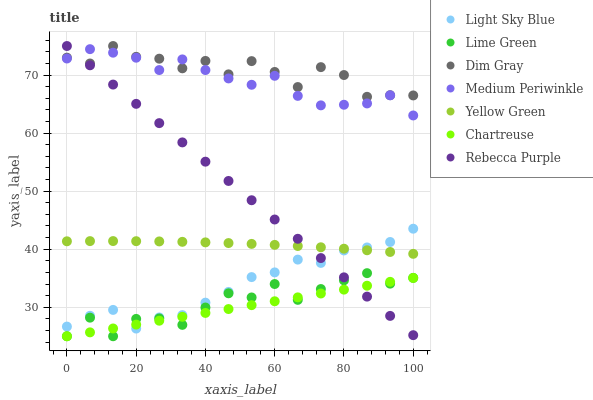Does Chartreuse have the minimum area under the curve?
Answer yes or no. Yes. Does Dim Gray have the maximum area under the curve?
Answer yes or no. Yes. Does Yellow Green have the minimum area under the curve?
Answer yes or no. No. Does Yellow Green have the maximum area under the curve?
Answer yes or no. No. Is Chartreuse the smoothest?
Answer yes or no. Yes. Is Dim Gray the roughest?
Answer yes or no. Yes. Is Yellow Green the smoothest?
Answer yes or no. No. Is Yellow Green the roughest?
Answer yes or no. No. Does Chartreuse have the lowest value?
Answer yes or no. Yes. Does Yellow Green have the lowest value?
Answer yes or no. No. Does Rebecca Purple have the highest value?
Answer yes or no. Yes. Does Yellow Green have the highest value?
Answer yes or no. No. Is Chartreuse less than Yellow Green?
Answer yes or no. Yes. Is Yellow Green greater than Lime Green?
Answer yes or no. Yes. Does Chartreuse intersect Light Sky Blue?
Answer yes or no. Yes. Is Chartreuse less than Light Sky Blue?
Answer yes or no. No. Is Chartreuse greater than Light Sky Blue?
Answer yes or no. No. Does Chartreuse intersect Yellow Green?
Answer yes or no. No. 